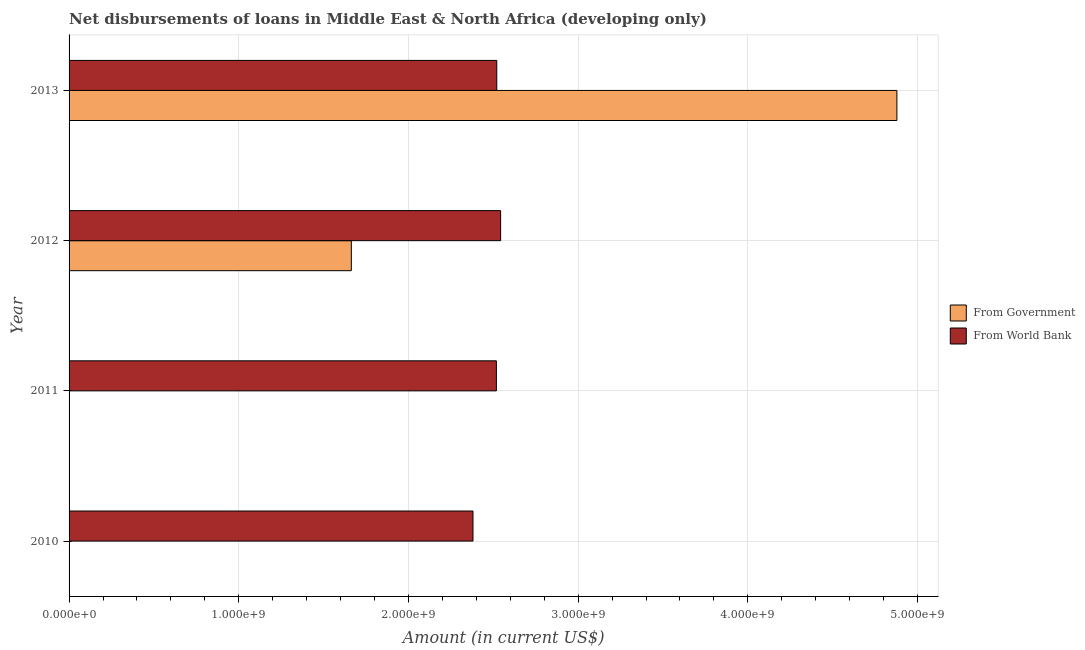How many different coloured bars are there?
Your answer should be very brief. 2. How many bars are there on the 2nd tick from the top?
Provide a short and direct response. 2. How many bars are there on the 1st tick from the bottom?
Provide a succinct answer. 1. What is the label of the 1st group of bars from the top?
Your response must be concise. 2013. In how many cases, is the number of bars for a given year not equal to the number of legend labels?
Offer a very short reply. 2. What is the net disbursements of loan from government in 2012?
Keep it short and to the point. 1.66e+09. Across all years, what is the maximum net disbursements of loan from world bank?
Offer a terse response. 2.54e+09. Across all years, what is the minimum net disbursements of loan from world bank?
Your answer should be very brief. 2.38e+09. What is the total net disbursements of loan from government in the graph?
Provide a succinct answer. 6.54e+09. What is the difference between the net disbursements of loan from world bank in 2010 and that in 2013?
Your response must be concise. -1.40e+08. What is the difference between the net disbursements of loan from world bank in 2011 and the net disbursements of loan from government in 2010?
Your answer should be very brief. 2.52e+09. What is the average net disbursements of loan from government per year?
Make the answer very short. 1.64e+09. In the year 2012, what is the difference between the net disbursements of loan from world bank and net disbursements of loan from government?
Offer a terse response. 8.80e+08. In how many years, is the net disbursements of loan from world bank greater than 4400000000 US$?
Make the answer very short. 0. Is the difference between the net disbursements of loan from world bank in 2012 and 2013 greater than the difference between the net disbursements of loan from government in 2012 and 2013?
Provide a succinct answer. Yes. What is the difference between the highest and the second highest net disbursements of loan from world bank?
Provide a succinct answer. 2.28e+07. What is the difference between the highest and the lowest net disbursements of loan from world bank?
Provide a short and direct response. 1.63e+08. Is the sum of the net disbursements of loan from world bank in 2010 and 2011 greater than the maximum net disbursements of loan from government across all years?
Offer a terse response. Yes. Are all the bars in the graph horizontal?
Keep it short and to the point. Yes. How many years are there in the graph?
Provide a succinct answer. 4. What is the difference between two consecutive major ticks on the X-axis?
Provide a short and direct response. 1.00e+09. Does the graph contain any zero values?
Ensure brevity in your answer.  Yes. Where does the legend appear in the graph?
Provide a succinct answer. Center right. How many legend labels are there?
Keep it short and to the point. 2. What is the title of the graph?
Your answer should be very brief. Net disbursements of loans in Middle East & North Africa (developing only). What is the label or title of the X-axis?
Offer a very short reply. Amount (in current US$). What is the label or title of the Y-axis?
Provide a short and direct response. Year. What is the Amount (in current US$) in From World Bank in 2010?
Your answer should be compact. 2.38e+09. What is the Amount (in current US$) in From Government in 2011?
Ensure brevity in your answer.  0. What is the Amount (in current US$) of From World Bank in 2011?
Offer a very short reply. 2.52e+09. What is the Amount (in current US$) in From Government in 2012?
Offer a very short reply. 1.66e+09. What is the Amount (in current US$) in From World Bank in 2012?
Provide a short and direct response. 2.54e+09. What is the Amount (in current US$) of From Government in 2013?
Your answer should be very brief. 4.88e+09. What is the Amount (in current US$) of From World Bank in 2013?
Ensure brevity in your answer.  2.52e+09. Across all years, what is the maximum Amount (in current US$) in From Government?
Your response must be concise. 4.88e+09. Across all years, what is the maximum Amount (in current US$) in From World Bank?
Make the answer very short. 2.54e+09. Across all years, what is the minimum Amount (in current US$) in From Government?
Your answer should be very brief. 0. Across all years, what is the minimum Amount (in current US$) of From World Bank?
Provide a short and direct response. 2.38e+09. What is the total Amount (in current US$) of From Government in the graph?
Offer a very short reply. 6.54e+09. What is the total Amount (in current US$) of From World Bank in the graph?
Keep it short and to the point. 9.96e+09. What is the difference between the Amount (in current US$) of From World Bank in 2010 and that in 2011?
Give a very brief answer. -1.38e+08. What is the difference between the Amount (in current US$) of From World Bank in 2010 and that in 2012?
Make the answer very short. -1.63e+08. What is the difference between the Amount (in current US$) in From World Bank in 2010 and that in 2013?
Your response must be concise. -1.40e+08. What is the difference between the Amount (in current US$) of From World Bank in 2011 and that in 2012?
Offer a terse response. -2.50e+07. What is the difference between the Amount (in current US$) in From World Bank in 2011 and that in 2013?
Offer a very short reply. -2.21e+06. What is the difference between the Amount (in current US$) of From Government in 2012 and that in 2013?
Make the answer very short. -3.21e+09. What is the difference between the Amount (in current US$) in From World Bank in 2012 and that in 2013?
Ensure brevity in your answer.  2.28e+07. What is the difference between the Amount (in current US$) of From Government in 2012 and the Amount (in current US$) of From World Bank in 2013?
Your answer should be compact. -8.57e+08. What is the average Amount (in current US$) of From Government per year?
Provide a succinct answer. 1.64e+09. What is the average Amount (in current US$) of From World Bank per year?
Ensure brevity in your answer.  2.49e+09. In the year 2012, what is the difference between the Amount (in current US$) of From Government and Amount (in current US$) of From World Bank?
Provide a short and direct response. -8.80e+08. In the year 2013, what is the difference between the Amount (in current US$) in From Government and Amount (in current US$) in From World Bank?
Provide a succinct answer. 2.36e+09. What is the ratio of the Amount (in current US$) in From World Bank in 2010 to that in 2011?
Offer a very short reply. 0.95. What is the ratio of the Amount (in current US$) of From World Bank in 2010 to that in 2012?
Offer a very short reply. 0.94. What is the ratio of the Amount (in current US$) in From World Bank in 2011 to that in 2012?
Provide a succinct answer. 0.99. What is the ratio of the Amount (in current US$) in From World Bank in 2011 to that in 2013?
Offer a terse response. 1. What is the ratio of the Amount (in current US$) in From Government in 2012 to that in 2013?
Your response must be concise. 0.34. What is the difference between the highest and the second highest Amount (in current US$) in From World Bank?
Offer a terse response. 2.28e+07. What is the difference between the highest and the lowest Amount (in current US$) in From Government?
Provide a succinct answer. 4.88e+09. What is the difference between the highest and the lowest Amount (in current US$) of From World Bank?
Make the answer very short. 1.63e+08. 